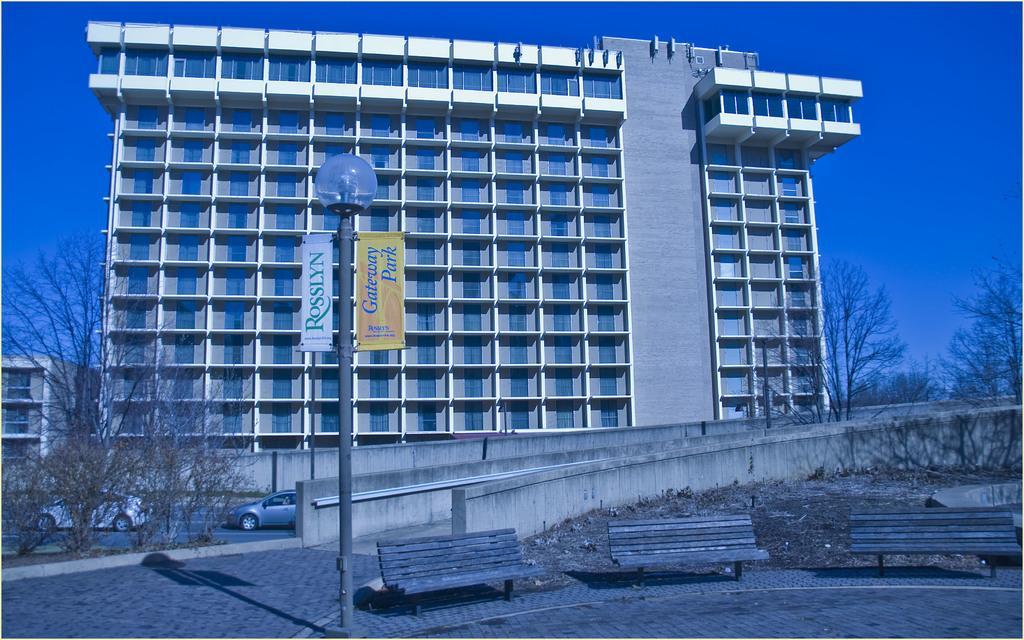Describe this image in one or two sentences. In the picture there is a building and in front of the building there are two cars and there is a tree on the left side and in the front there is a pavement and on that pavement there are three benches, on the left side there is pole light and there are two banners attached to that pole light and there are some other trees on the right side. 